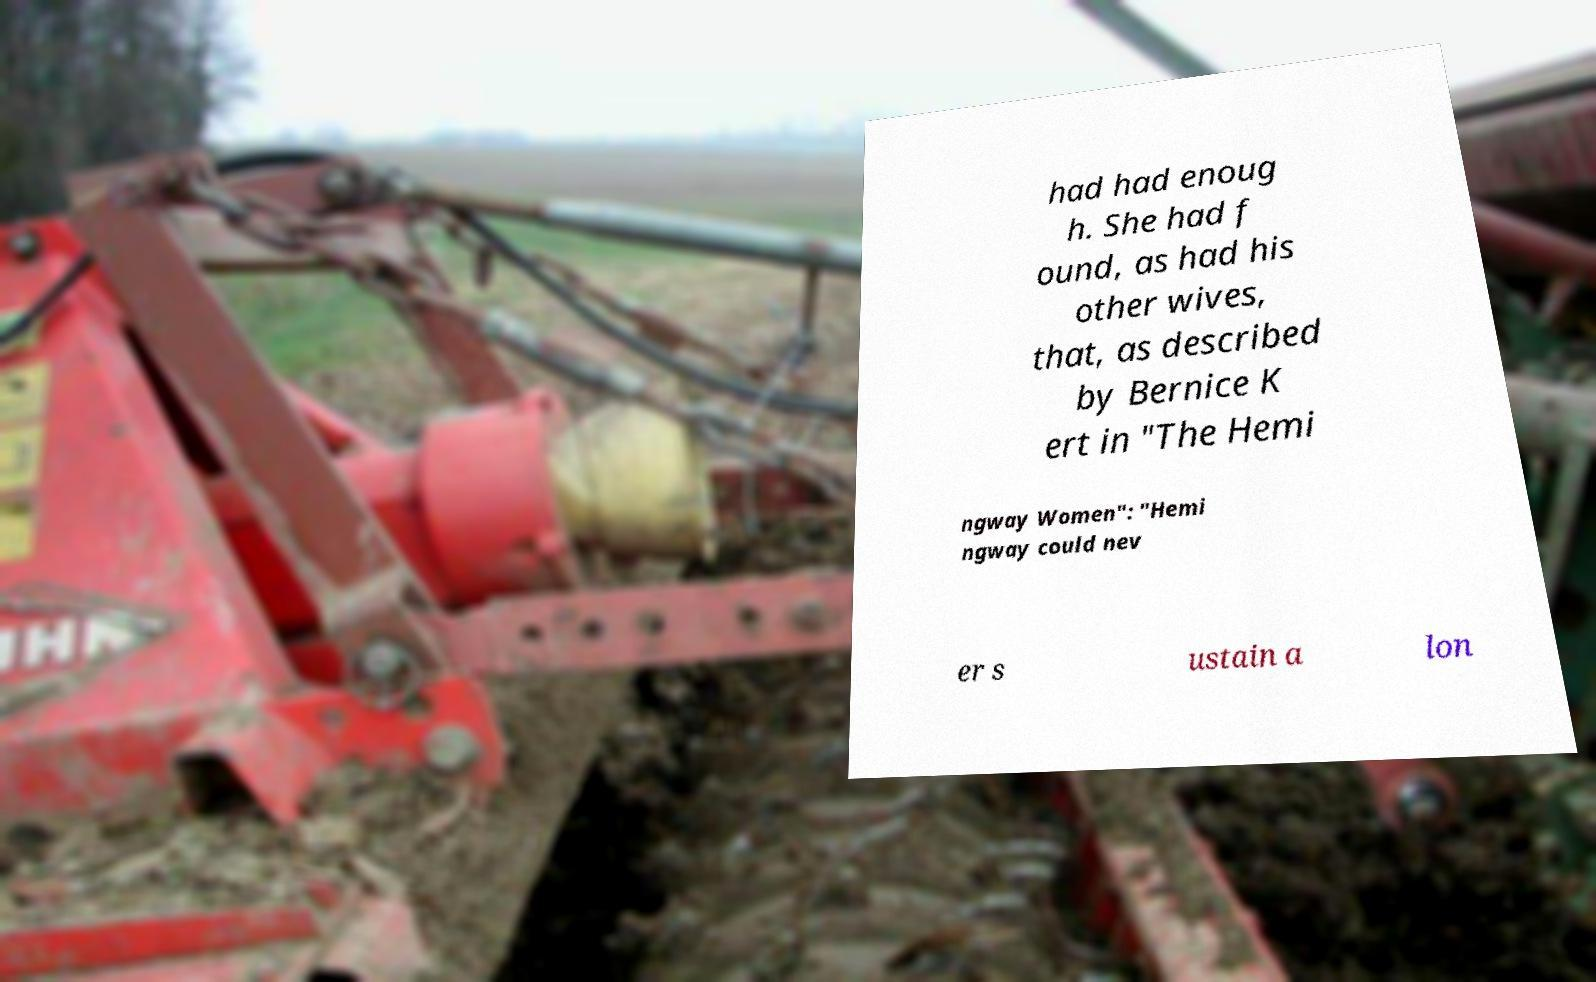For documentation purposes, I need the text within this image transcribed. Could you provide that? had had enoug h. She had f ound, as had his other wives, that, as described by Bernice K ert in "The Hemi ngway Women": "Hemi ngway could nev er s ustain a lon 